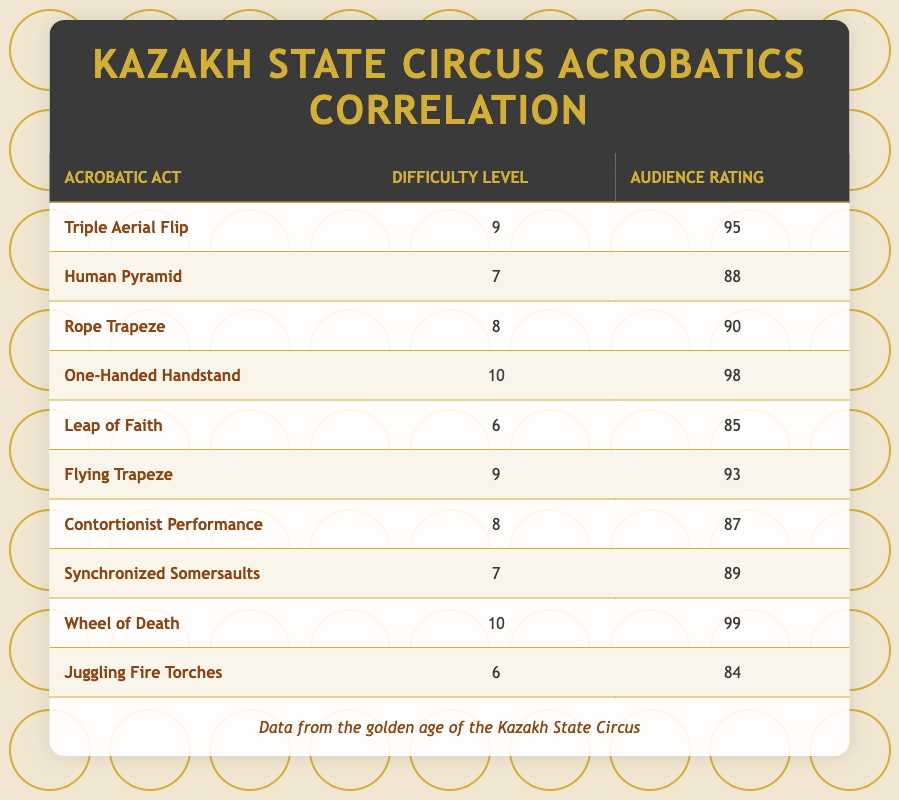What is the audience rating for the "One-Handed Handstand" act? The audience rating for the "One-Handed Handstand" act is listed directly in the table, which states a rating of 98.
Answer: 98 Which acrobatic act has the highest difficulty level? In the table, both the "One-Handed Handstand" and "Wheel of Death" acts have a difficulty level of 10, making them the highest.
Answer: One-Handed Handstand and Wheel of Death What is the average audience rating of acts with a difficulty level of 8? The acts with a difficulty level of 8 are "Rope Trapeze," "Contortionist Performance," and "Synchronized Somersaults." Their audience ratings are 90, 87, and 89, respectively. The sum is 90 + 87 + 89 = 266, and the average is 266 / 3 = 88.67.
Answer: 88.67 Is it true that a higher difficulty level always results in a higher audience rating? In the table, while most high difficulty acts have high audience ratings, "Leap of Faith," which has a difficulty of 6, has a lower rating than some acts with higher difficulty levels. This indicates that a higher difficulty does not always ensure a higher audience rating.
Answer: No What is the difference in audience ratings between the acts "Triple Aerial Flip" and "Juggling Fire Torches"? The audience rating for "Triple Aerial Flip" is 95 and for "Juggling Fire Torches" is 84. To find the difference, subtract the lower rating from the higher one: 95 - 84 = 11.
Answer: 11 